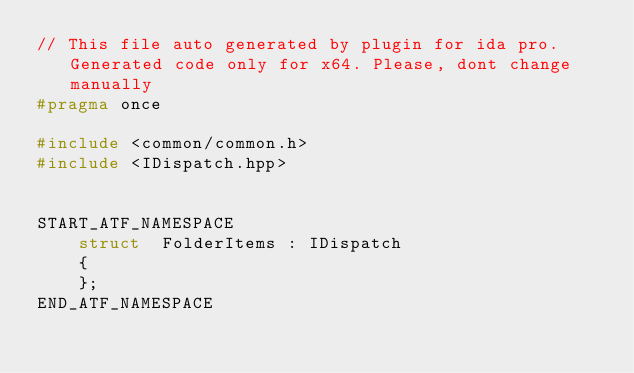<code> <loc_0><loc_0><loc_500><loc_500><_C++_>// This file auto generated by plugin for ida pro. Generated code only for x64. Please, dont change manually
#pragma once

#include <common/common.h>
#include <IDispatch.hpp>


START_ATF_NAMESPACE
    struct  FolderItems : IDispatch
    {
    };
END_ATF_NAMESPACE
</code> 